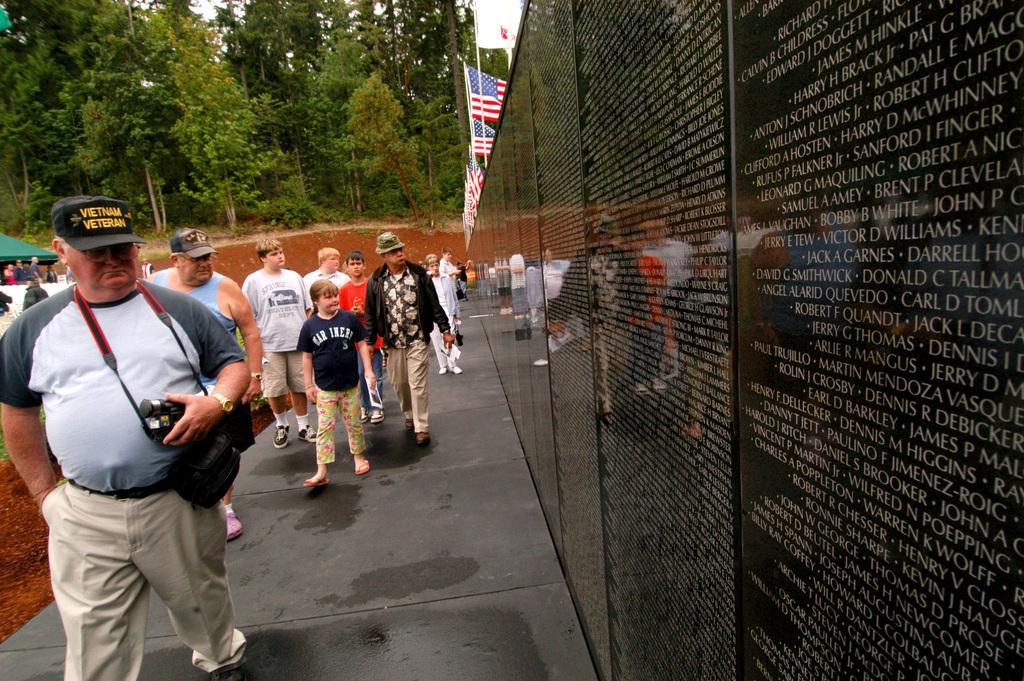In one or two sentences, can you explain what this image depicts? This image consists of many people walking on the road. In the front, the man is holding a camera. On the right, we can see black stones on the wall. On which there is text. At the top, there are flags. In the background, there are many trees. 